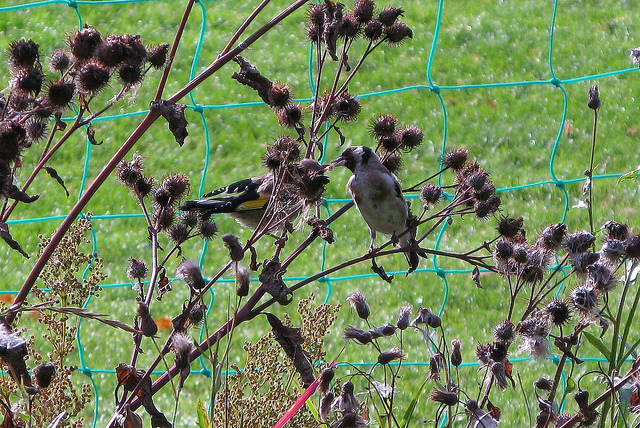Are these plants native to a particular region or climate? Burdock, the plant visible in this image, is native to Eurasia but has become widespread across many regions including North America. It thrives in a variety of climates but is typically found in disturbed areas like roadsides and empty fields where the soil is rich and has been recently turned. 